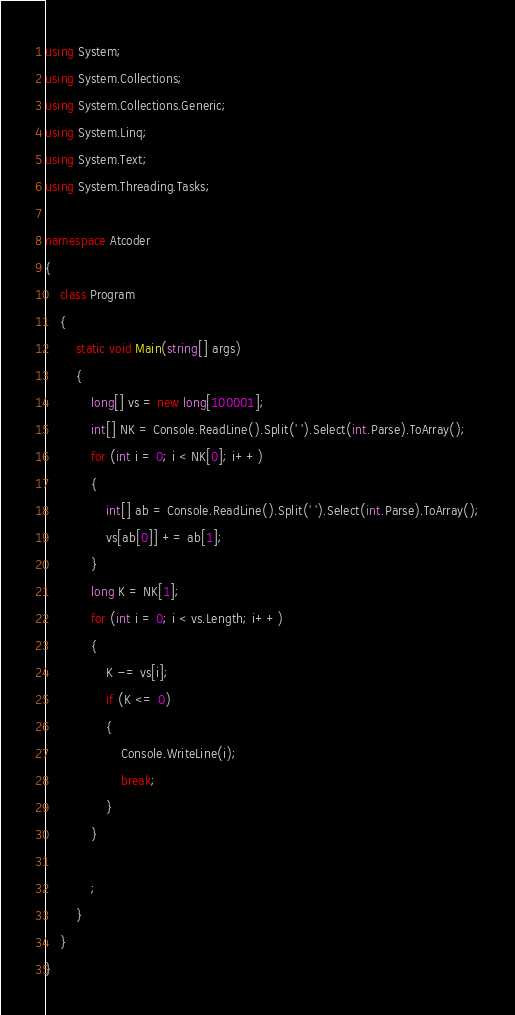<code> <loc_0><loc_0><loc_500><loc_500><_C#_>using System;
using System.Collections;
using System.Collections.Generic;
using System.Linq;
using System.Text;
using System.Threading.Tasks;

namespace Atcoder
{
    class Program
    {
        static void Main(string[] args)
        {
            long[] vs = new long[100001];
            int[] NK = Console.ReadLine().Split(' ').Select(int.Parse).ToArray();
            for (int i = 0; i < NK[0]; i++)
            {
                int[] ab = Console.ReadLine().Split(' ').Select(int.Parse).ToArray();
                vs[ab[0]] += ab[1];
            }
            long K = NK[1];
            for (int i = 0; i < vs.Length; i++)
            {
                K -= vs[i];
                if (K <= 0)
                {
                    Console.WriteLine(i);
                    break;
                }
            }

            ;
        }
    }
}
</code> 